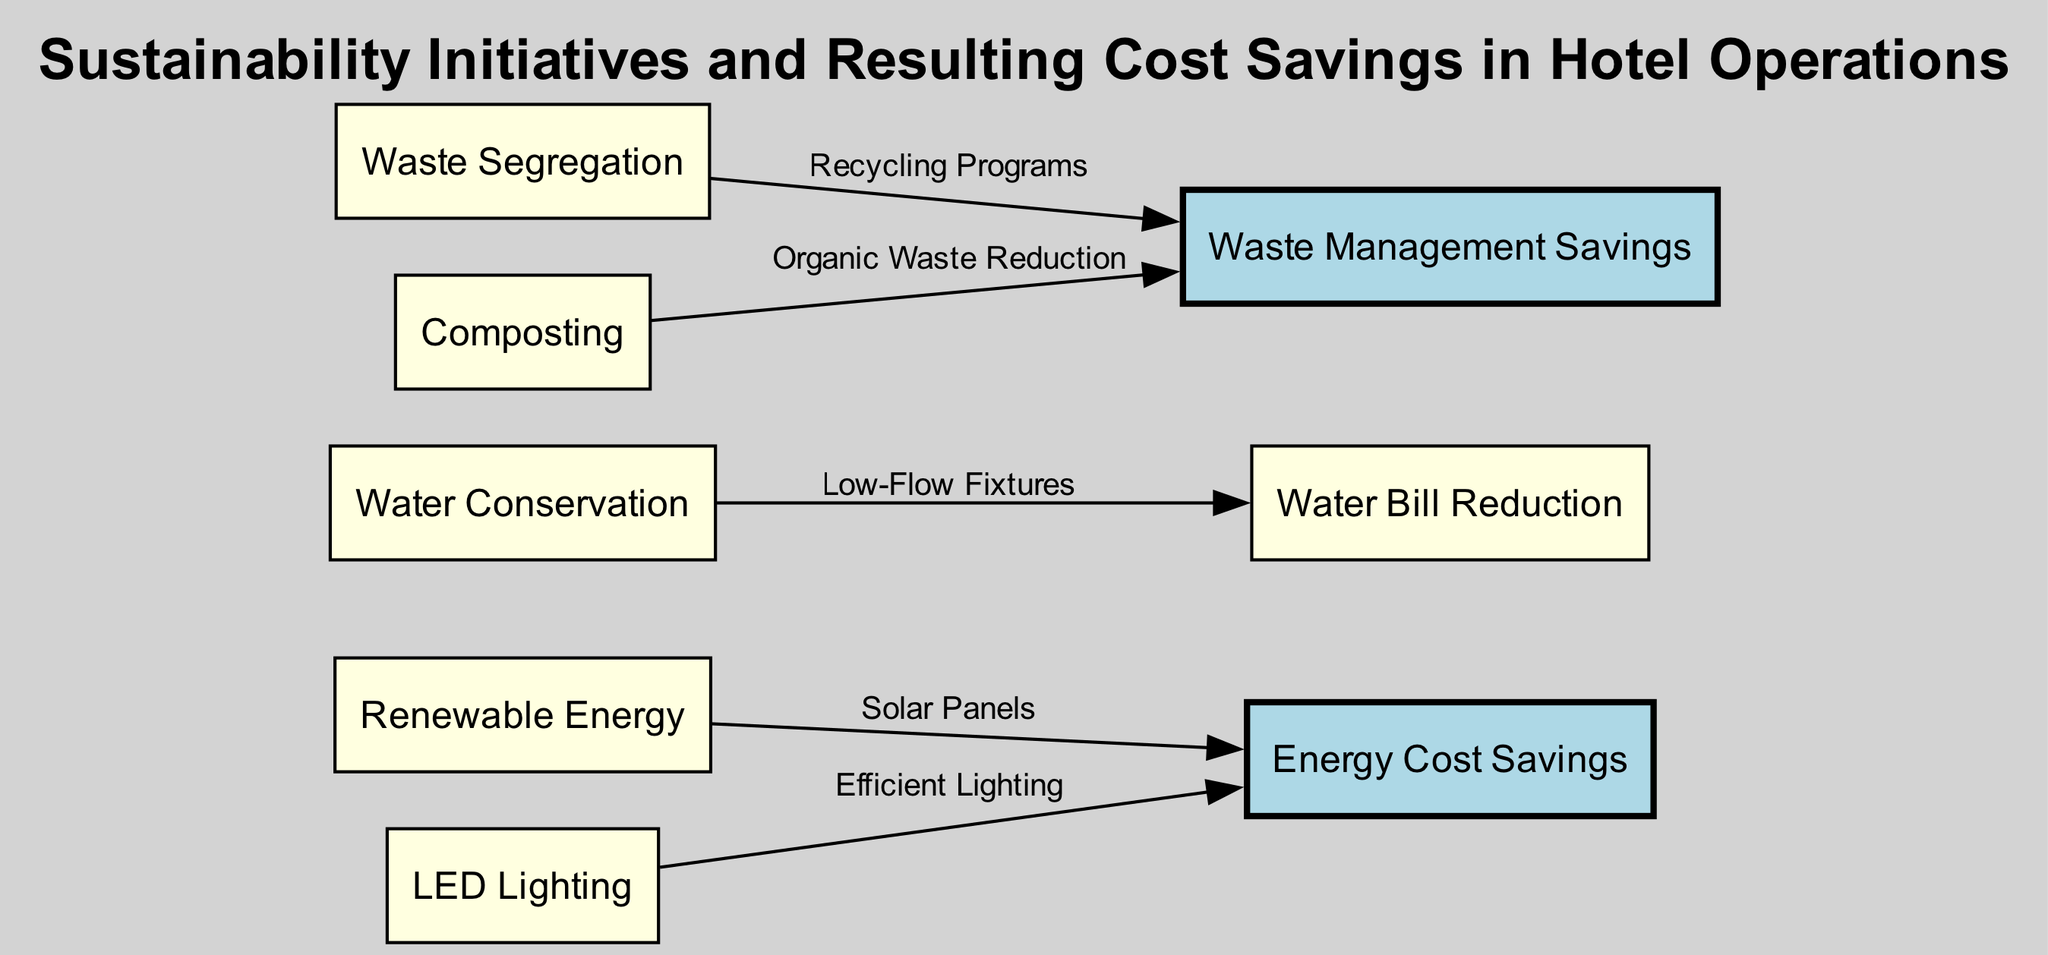What is the total number of nodes in the diagram? The diagram has several nodes representing sustainability initiatives and resulting savings. By counting each individual entry in the nodes section, we find there are 8 nodes total.
Answer: 8 Which initiative is associated with energy cost savings through 'Solar Panels'? In the edges section, the connection from 'renewable_energy' to 'energy_costs_savings' is labeled as 'Solar Panels'. This indicates that the renewable energy initiative contributes to energy cost savings via solar panels.
Answer: Renewable Energy What type of lighting is shown to lead to energy cost savings? The node labeled 'LED Lighting' in the diagram is connected to 'energy_costs_savings', indicating that LED lighting is identified as a measure for achieving energy savings.
Answer: LED Lighting How many methods are connected to waste management savings? By examining the diagram's edges, we note there are two nodes connected to 'waste_management_savings': 'waste_segregation' and 'composting'. Counting these connections reveals a total of two methods.
Answer: 2 What monetary benefit is associated with water conservation? The edge labeled 'Low-Flow Fixtures' connects 'water_conservation' to 'water_bill_reduction', suggesting that the monetary benefit linked with water conservation measures is a reduction in water bills.
Answer: Water Bill Reduction How do waste segregation initiatives help financially? The waste segregation initiative leads to 'waste_management_savings' through the connection labeled 'Recycling Programs', highlighting that effective waste segregation results in financial savings.
Answer: Waste Management Savings Which sustainability initiative directly reduces water bills? The initiative related to reducing water bills is 'Water Conservation', as indicated in the edge labeled 'Low-Flow Fixtures' linking it to 'water_bill_reduction'.
Answer: Water Conservation What is the financial benefit of composting? Composting contributes to 'waste_management_savings' as seen in the edge labeled 'Organic Waste Reduction', demonstrating that composting is financially beneficial for waste management.
Answer: Waste Management Savings 